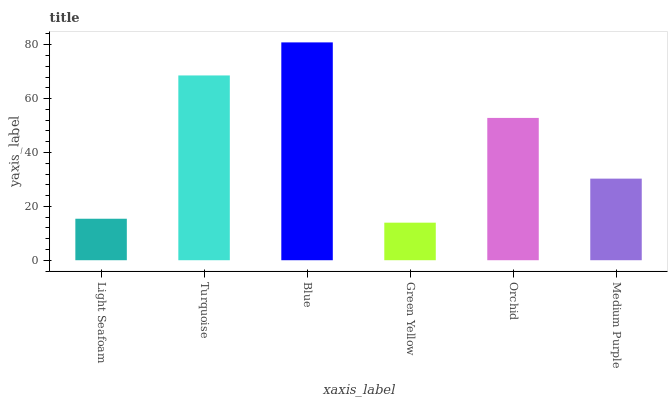Is Turquoise the minimum?
Answer yes or no. No. Is Turquoise the maximum?
Answer yes or no. No. Is Turquoise greater than Light Seafoam?
Answer yes or no. Yes. Is Light Seafoam less than Turquoise?
Answer yes or no. Yes. Is Light Seafoam greater than Turquoise?
Answer yes or no. No. Is Turquoise less than Light Seafoam?
Answer yes or no. No. Is Orchid the high median?
Answer yes or no. Yes. Is Medium Purple the low median?
Answer yes or no. Yes. Is Light Seafoam the high median?
Answer yes or no. No. Is Orchid the low median?
Answer yes or no. No. 